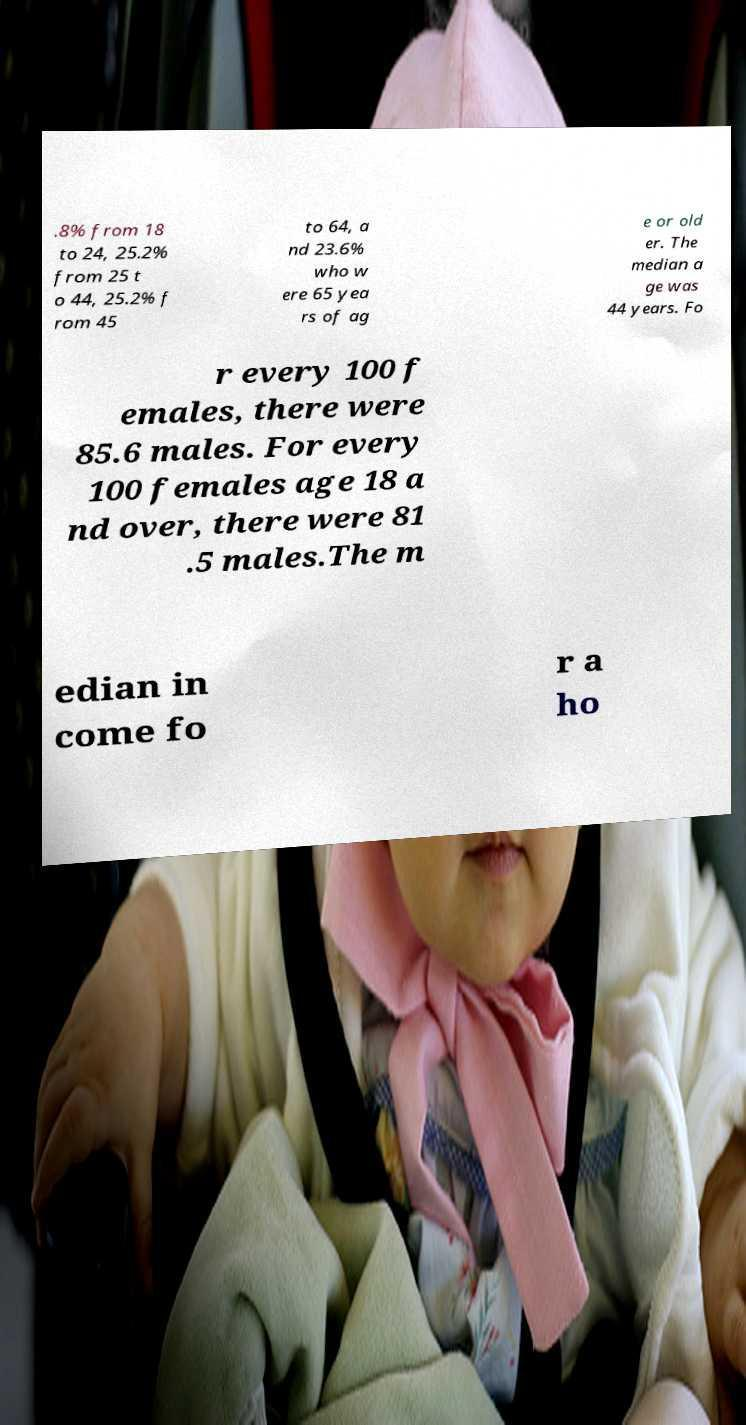Please read and relay the text visible in this image. What does it say? .8% from 18 to 24, 25.2% from 25 t o 44, 25.2% f rom 45 to 64, a nd 23.6% who w ere 65 yea rs of ag e or old er. The median a ge was 44 years. Fo r every 100 f emales, there were 85.6 males. For every 100 females age 18 a nd over, there were 81 .5 males.The m edian in come fo r a ho 